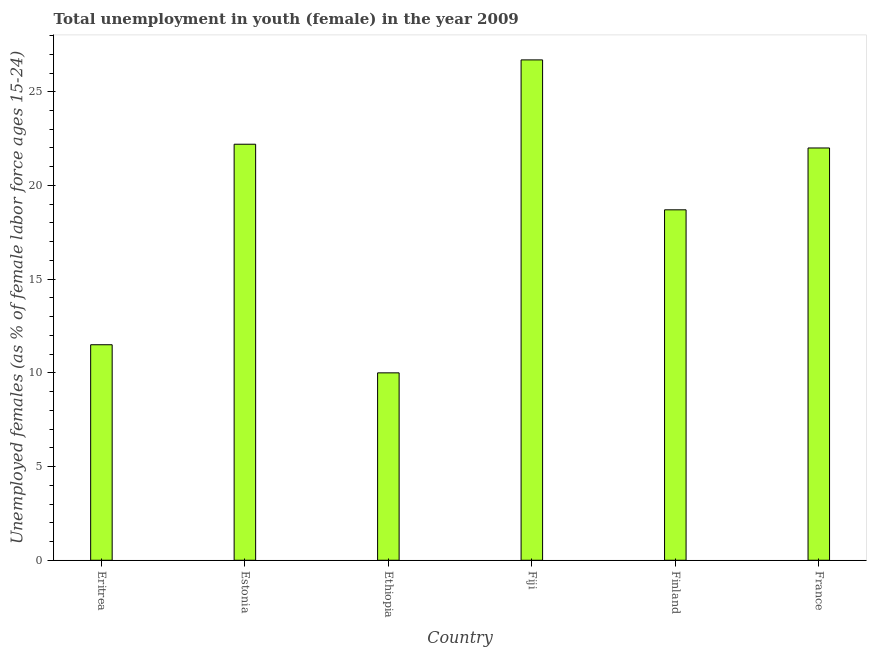Does the graph contain any zero values?
Make the answer very short. No. Does the graph contain grids?
Your answer should be very brief. No. What is the title of the graph?
Keep it short and to the point. Total unemployment in youth (female) in the year 2009. What is the label or title of the X-axis?
Offer a terse response. Country. What is the label or title of the Y-axis?
Make the answer very short. Unemployed females (as % of female labor force ages 15-24). Across all countries, what is the maximum unemployed female youth population?
Ensure brevity in your answer.  26.7. In which country was the unemployed female youth population maximum?
Offer a very short reply. Fiji. In which country was the unemployed female youth population minimum?
Keep it short and to the point. Ethiopia. What is the sum of the unemployed female youth population?
Ensure brevity in your answer.  111.1. What is the difference between the unemployed female youth population in Ethiopia and Fiji?
Provide a succinct answer. -16.7. What is the average unemployed female youth population per country?
Provide a short and direct response. 18.52. What is the median unemployed female youth population?
Ensure brevity in your answer.  20.35. What is the ratio of the unemployed female youth population in Eritrea to that in Ethiopia?
Keep it short and to the point. 1.15. Is the unemployed female youth population in Finland less than that in France?
Provide a succinct answer. Yes. Is the sum of the unemployed female youth population in Ethiopia and France greater than the maximum unemployed female youth population across all countries?
Your answer should be very brief. Yes. How many bars are there?
Provide a succinct answer. 6. How many countries are there in the graph?
Provide a succinct answer. 6. What is the Unemployed females (as % of female labor force ages 15-24) of Estonia?
Your answer should be compact. 22.2. What is the Unemployed females (as % of female labor force ages 15-24) in Ethiopia?
Provide a succinct answer. 10. What is the Unemployed females (as % of female labor force ages 15-24) of Fiji?
Make the answer very short. 26.7. What is the Unemployed females (as % of female labor force ages 15-24) in Finland?
Your answer should be compact. 18.7. What is the Unemployed females (as % of female labor force ages 15-24) of France?
Make the answer very short. 22. What is the difference between the Unemployed females (as % of female labor force ages 15-24) in Eritrea and Fiji?
Provide a short and direct response. -15.2. What is the difference between the Unemployed females (as % of female labor force ages 15-24) in Estonia and Ethiopia?
Your answer should be compact. 12.2. What is the difference between the Unemployed females (as % of female labor force ages 15-24) in Estonia and France?
Make the answer very short. 0.2. What is the difference between the Unemployed females (as % of female labor force ages 15-24) in Ethiopia and Fiji?
Provide a short and direct response. -16.7. What is the difference between the Unemployed females (as % of female labor force ages 15-24) in Ethiopia and Finland?
Provide a succinct answer. -8.7. What is the difference between the Unemployed females (as % of female labor force ages 15-24) in Finland and France?
Keep it short and to the point. -3.3. What is the ratio of the Unemployed females (as % of female labor force ages 15-24) in Eritrea to that in Estonia?
Provide a succinct answer. 0.52. What is the ratio of the Unemployed females (as % of female labor force ages 15-24) in Eritrea to that in Ethiopia?
Keep it short and to the point. 1.15. What is the ratio of the Unemployed females (as % of female labor force ages 15-24) in Eritrea to that in Fiji?
Your answer should be compact. 0.43. What is the ratio of the Unemployed females (as % of female labor force ages 15-24) in Eritrea to that in Finland?
Provide a succinct answer. 0.61. What is the ratio of the Unemployed females (as % of female labor force ages 15-24) in Eritrea to that in France?
Ensure brevity in your answer.  0.52. What is the ratio of the Unemployed females (as % of female labor force ages 15-24) in Estonia to that in Ethiopia?
Ensure brevity in your answer.  2.22. What is the ratio of the Unemployed females (as % of female labor force ages 15-24) in Estonia to that in Fiji?
Ensure brevity in your answer.  0.83. What is the ratio of the Unemployed females (as % of female labor force ages 15-24) in Estonia to that in Finland?
Ensure brevity in your answer.  1.19. What is the ratio of the Unemployed females (as % of female labor force ages 15-24) in Ethiopia to that in Finland?
Give a very brief answer. 0.54. What is the ratio of the Unemployed females (as % of female labor force ages 15-24) in Ethiopia to that in France?
Your response must be concise. 0.46. What is the ratio of the Unemployed females (as % of female labor force ages 15-24) in Fiji to that in Finland?
Ensure brevity in your answer.  1.43. What is the ratio of the Unemployed females (as % of female labor force ages 15-24) in Fiji to that in France?
Provide a short and direct response. 1.21. 